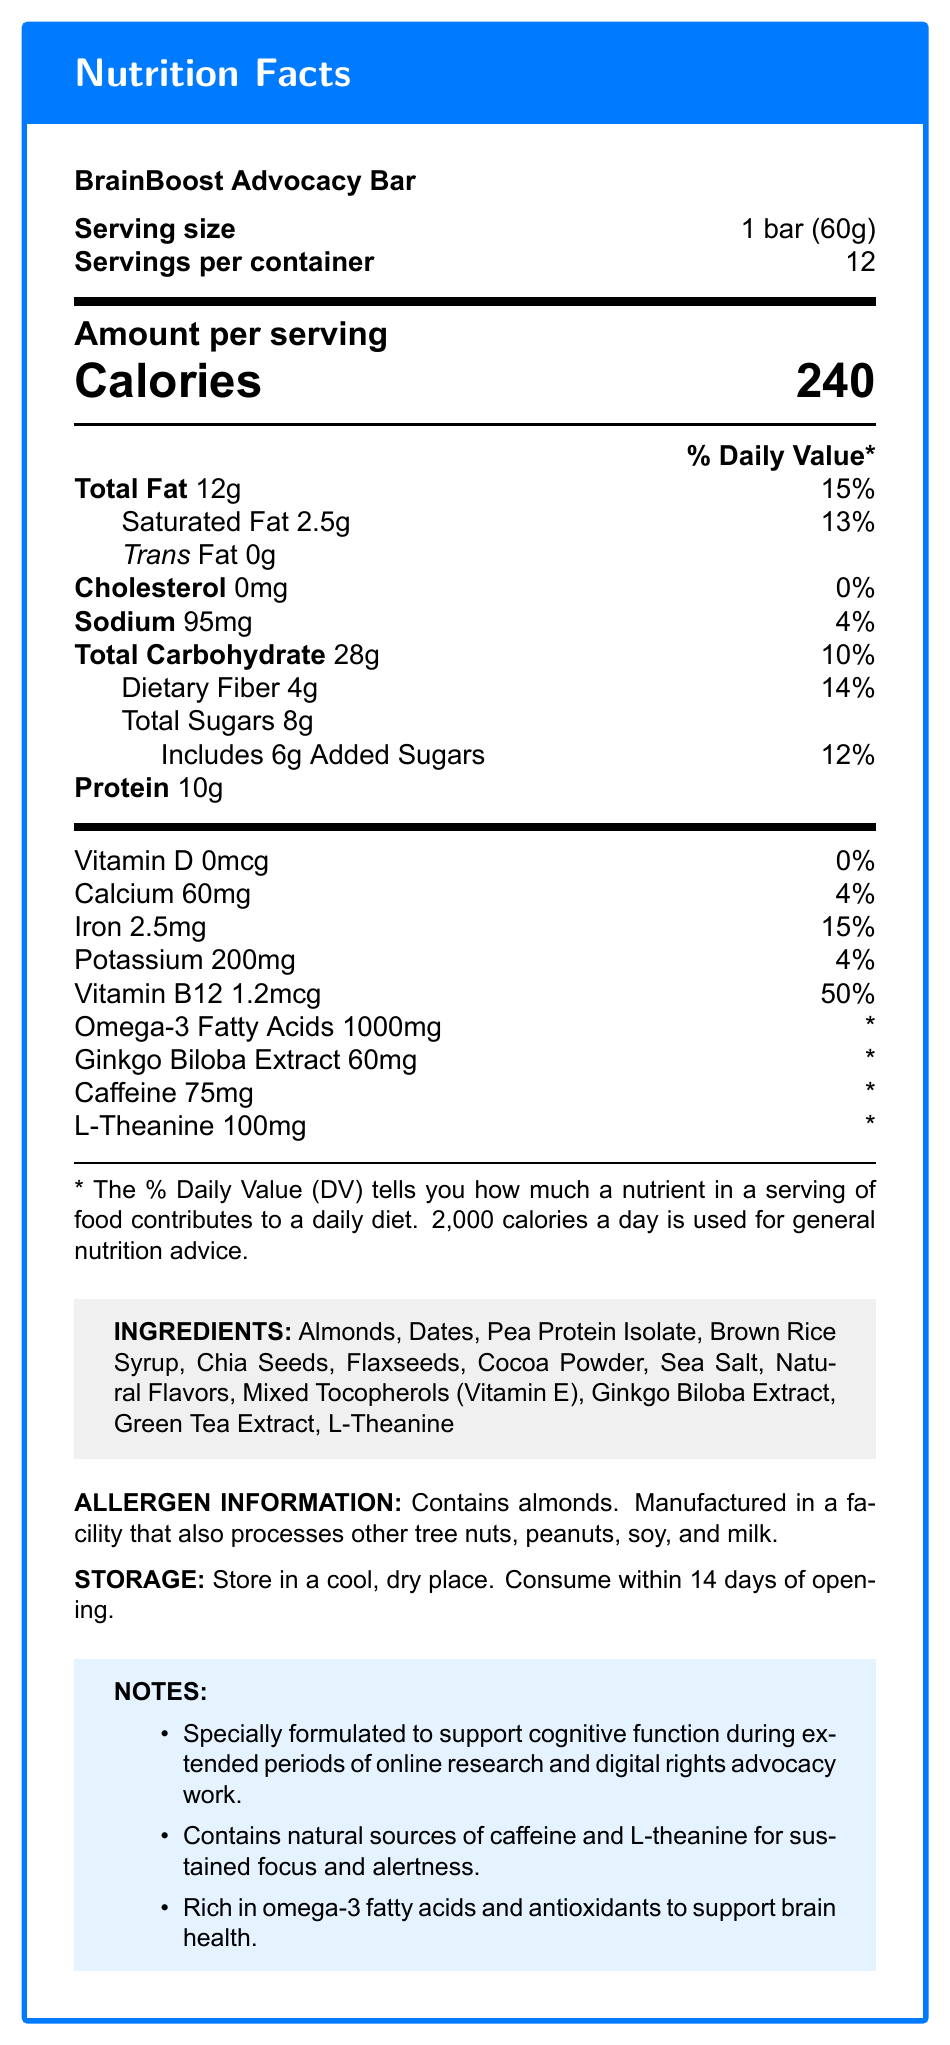who is the target audience for the BrainBoost Advocacy Bar? The document specifies that the product is "specially formulated to support cognitive function during extended periods of online research and digital rights advocacy work."
Answer: Digital rights advocates and individuals engaging in extended periods of online research what is the serving size of the BrainBoost Advocacy Bar? The serving size is explicitly stated in the document as "1 bar (60g)."
Answer: 1 bar (60g) how many calories are in one serving of the BrainBoost Advocacy Bar? The document lists "Calories 240" under the amount per serving section.
Answer: 240 calories what are the main ingredients in the BrainBoost Advocacy Bar? The ingredients are listed in a dedicated section under "INGREDIENTS."
Answer: Almonds, Dates, Pea Protein Isolate, Brown Rice Syrup, Chia Seeds, Flaxseeds, Cocoa Powder, Sea Salt, Natural Flavors, Mixed Tocopherols (Vitamin E), Ginkgo Biloba Extract, Green Tea Extract, L-Theanine how much protein does one bar contain? The amount of protein per bar is listed as "Protein 10g" in the nutrition facts table.
Answer: 10g what is the daily value percentage of saturated fat in one serving? A. 7% B. 13% C. 20% D. 25% The daily value percentage for saturated fat is listed as "Saturated Fat 2.5g 13%" in the nutrition facts table.
Answer: B. 13% how much L-Theanine is in one serving of the BrainBoost Advocacy Bar? A. 50mg B. 75mg C. 100mg D. 150mg The amount of L-Theanine per serving is listed as "L-Theanine 100mg" in the nutrition facts table.
Answer: C. 100mg does the product contain any added sugars? It is listed in the nutrition facts table as "Includes 6g Added Sugars 12%."
Answer: Yes is the BrainBoost Advocacy Bar gluten-free? The document does not provide information on whether the product is gluten-free.
Answer: Not enough information how should the BrainBoost Advocacy Bar be stored? The storage instructions are detailed under the "STORAGE" section in the document.
Answer: Store in a cool, dry place. Consume within 14 days of opening. summarize the main purpose of the BrainBoost Advocacy Bar. The summary encapsulates the core purpose and benefits of the bar as detailed in the document.
Answer: The BrainBoost Advocacy Bar is a snack bar designed to support cognitive function and sustained focus during long periods of online research and digital rights advocacy work. It contains ingredients like caffeine, L-Theanine, omega-3 fatty acids, and ginkgo biloba extract to enhance brain health and alertness. what allergens are present in the BrainBoost Advocacy Bar? The allergen information section states that the product contains almonds and may be cross-contaminated with other allergens.
Answer: Almonds. Manufactured in a facility that also processes other tree nuts, peanuts, soy, and milk. does the BrainBoost Advocacy Bar contain ginkgo biloba extract? Ginkgo Biloba Extract is explicitly listed as an ingredient and in the nutrition facts table.
Answer: Yes how many servings are in each container of BrainBoost Advocacy Bar? The document lists "Servings per container: 12."
Answer: 12 what is the main benefit of including omega-3 fatty acids in the BrainBoost Advocacy Bar? The additional notes section states that the product is "rich in omega-3 fatty acids and antioxidants to support brain health."
Answer: To support brain health 